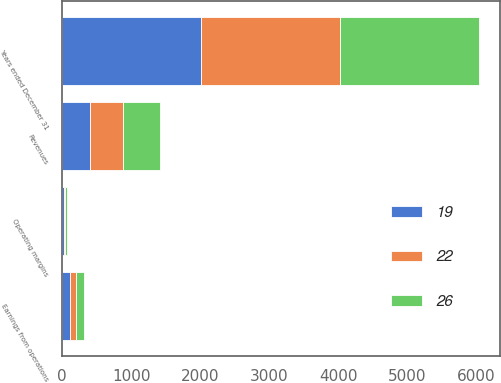Convert chart to OTSL. <chart><loc_0><loc_0><loc_500><loc_500><stacked_bar_chart><ecel><fcel>Years ended December 31<fcel>Revenues<fcel>Earnings from operations<fcel>Operating margins<nl><fcel>19<fcel>2013<fcel>408<fcel>107<fcel>26<nl><fcel>22<fcel>2012<fcel>468<fcel>88<fcel>19<nl><fcel>26<fcel>2011<fcel>547<fcel>119<fcel>22<nl></chart> 